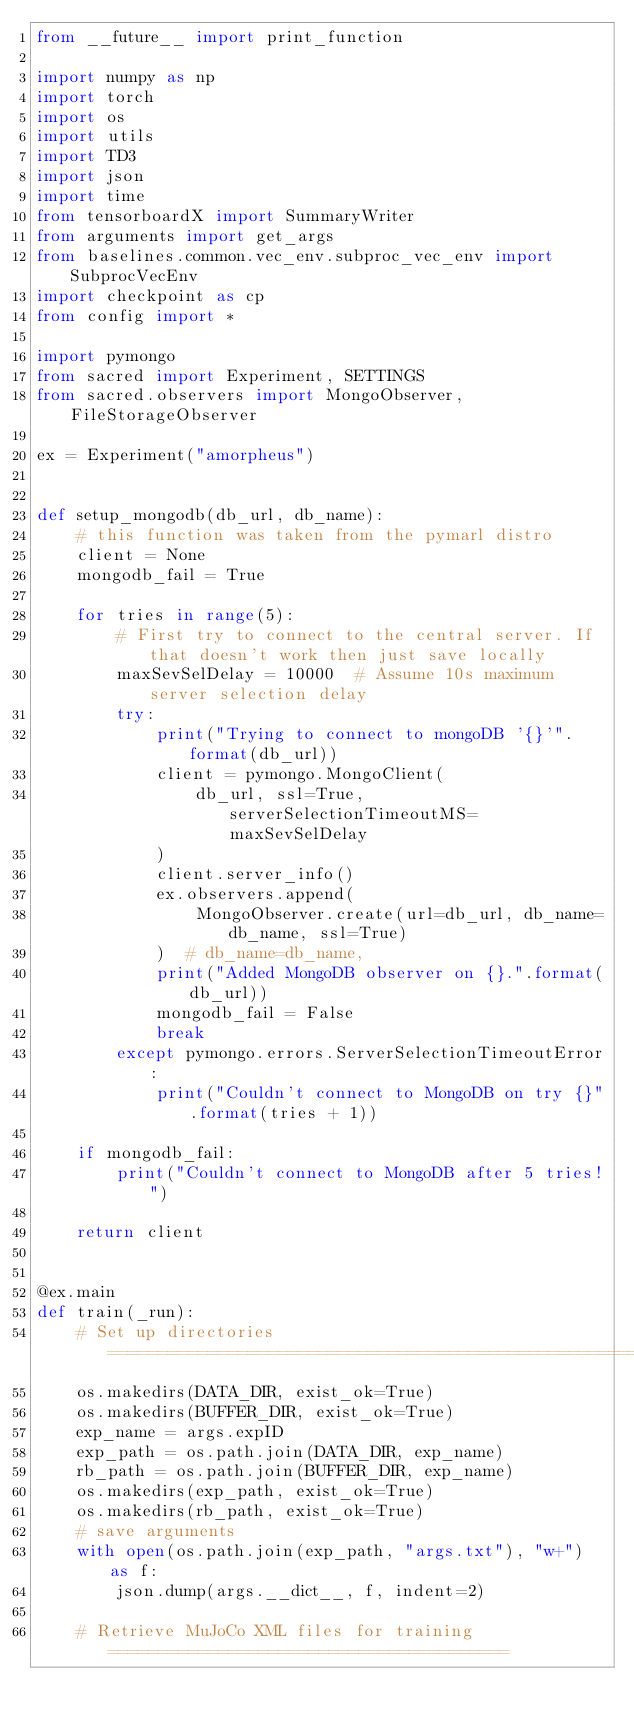Convert code to text. <code><loc_0><loc_0><loc_500><loc_500><_Python_>from __future__ import print_function

import numpy as np
import torch
import os
import utils
import TD3
import json
import time
from tensorboardX import SummaryWriter
from arguments import get_args
from baselines.common.vec_env.subproc_vec_env import SubprocVecEnv
import checkpoint as cp
from config import *

import pymongo
from sacred import Experiment, SETTINGS
from sacred.observers import MongoObserver, FileStorageObserver

ex = Experiment("amorpheus")


def setup_mongodb(db_url, db_name):
    # this function was taken from the pymarl distro
    client = None
    mongodb_fail = True

    for tries in range(5):
        # First try to connect to the central server. If that doesn't work then just save locally
        maxSevSelDelay = 10000  # Assume 10s maximum server selection delay
        try:
            print("Trying to connect to mongoDB '{}'".format(db_url))
            client = pymongo.MongoClient(
                db_url, ssl=True, serverSelectionTimeoutMS=maxSevSelDelay
            )
            client.server_info()
            ex.observers.append(
                MongoObserver.create(url=db_url, db_name=db_name, ssl=True)
            )  # db_name=db_name,
            print("Added MongoDB observer on {}.".format(db_url))
            mongodb_fail = False
            break
        except pymongo.errors.ServerSelectionTimeoutError:
            print("Couldn't connect to MongoDB on try {}".format(tries + 1))

    if mongodb_fail:
        print("Couldn't connect to MongoDB after 5 tries!")

    return client


@ex.main
def train(_run):
    # Set up directories ===========================================================
    os.makedirs(DATA_DIR, exist_ok=True)
    os.makedirs(BUFFER_DIR, exist_ok=True)
    exp_name = args.expID
    exp_path = os.path.join(DATA_DIR, exp_name)
    rb_path = os.path.join(BUFFER_DIR, exp_name)
    os.makedirs(exp_path, exist_ok=True)
    os.makedirs(rb_path, exist_ok=True)
    # save arguments
    with open(os.path.join(exp_path, "args.txt"), "w+") as f:
        json.dump(args.__dict__, f, indent=2)

    # Retrieve MuJoCo XML files for training ========================================</code> 